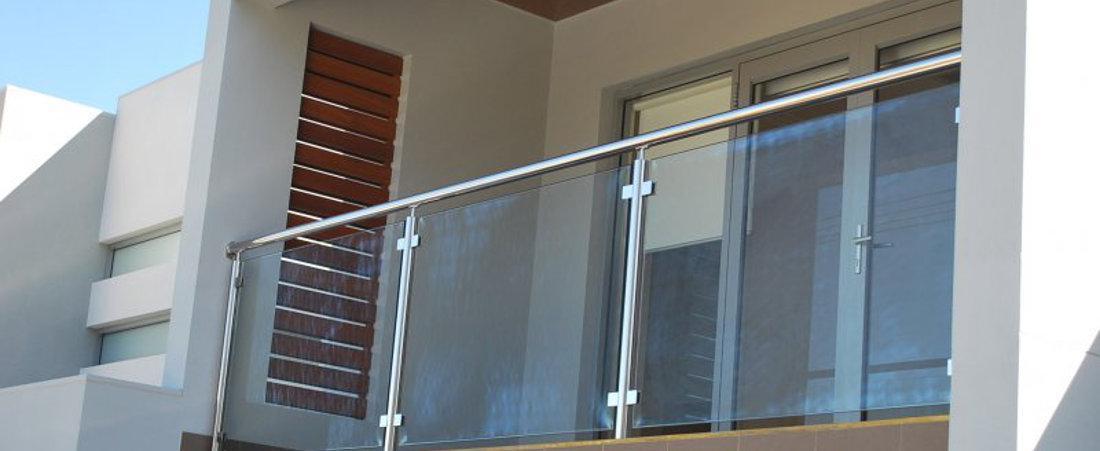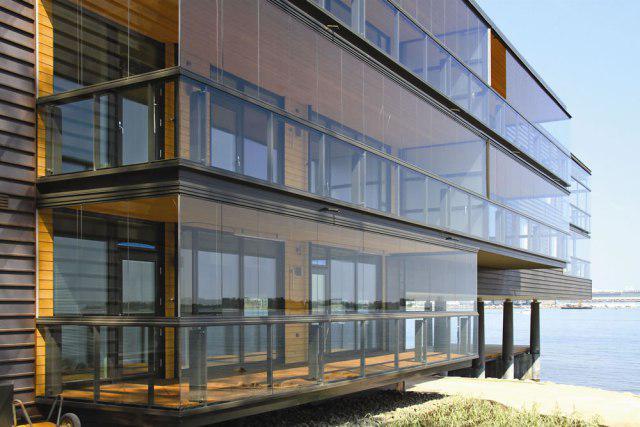The first image is the image on the left, the second image is the image on the right. Examine the images to the left and right. Is the description "The right image contains at least three balconies on a building." accurate? Answer yes or no. Yes. The first image is the image on the left, the second image is the image on the right. Evaluate the accuracy of this statement regarding the images: "A building with at least 3 stories has glass deck railings outside.". Is it true? Answer yes or no. Yes. 